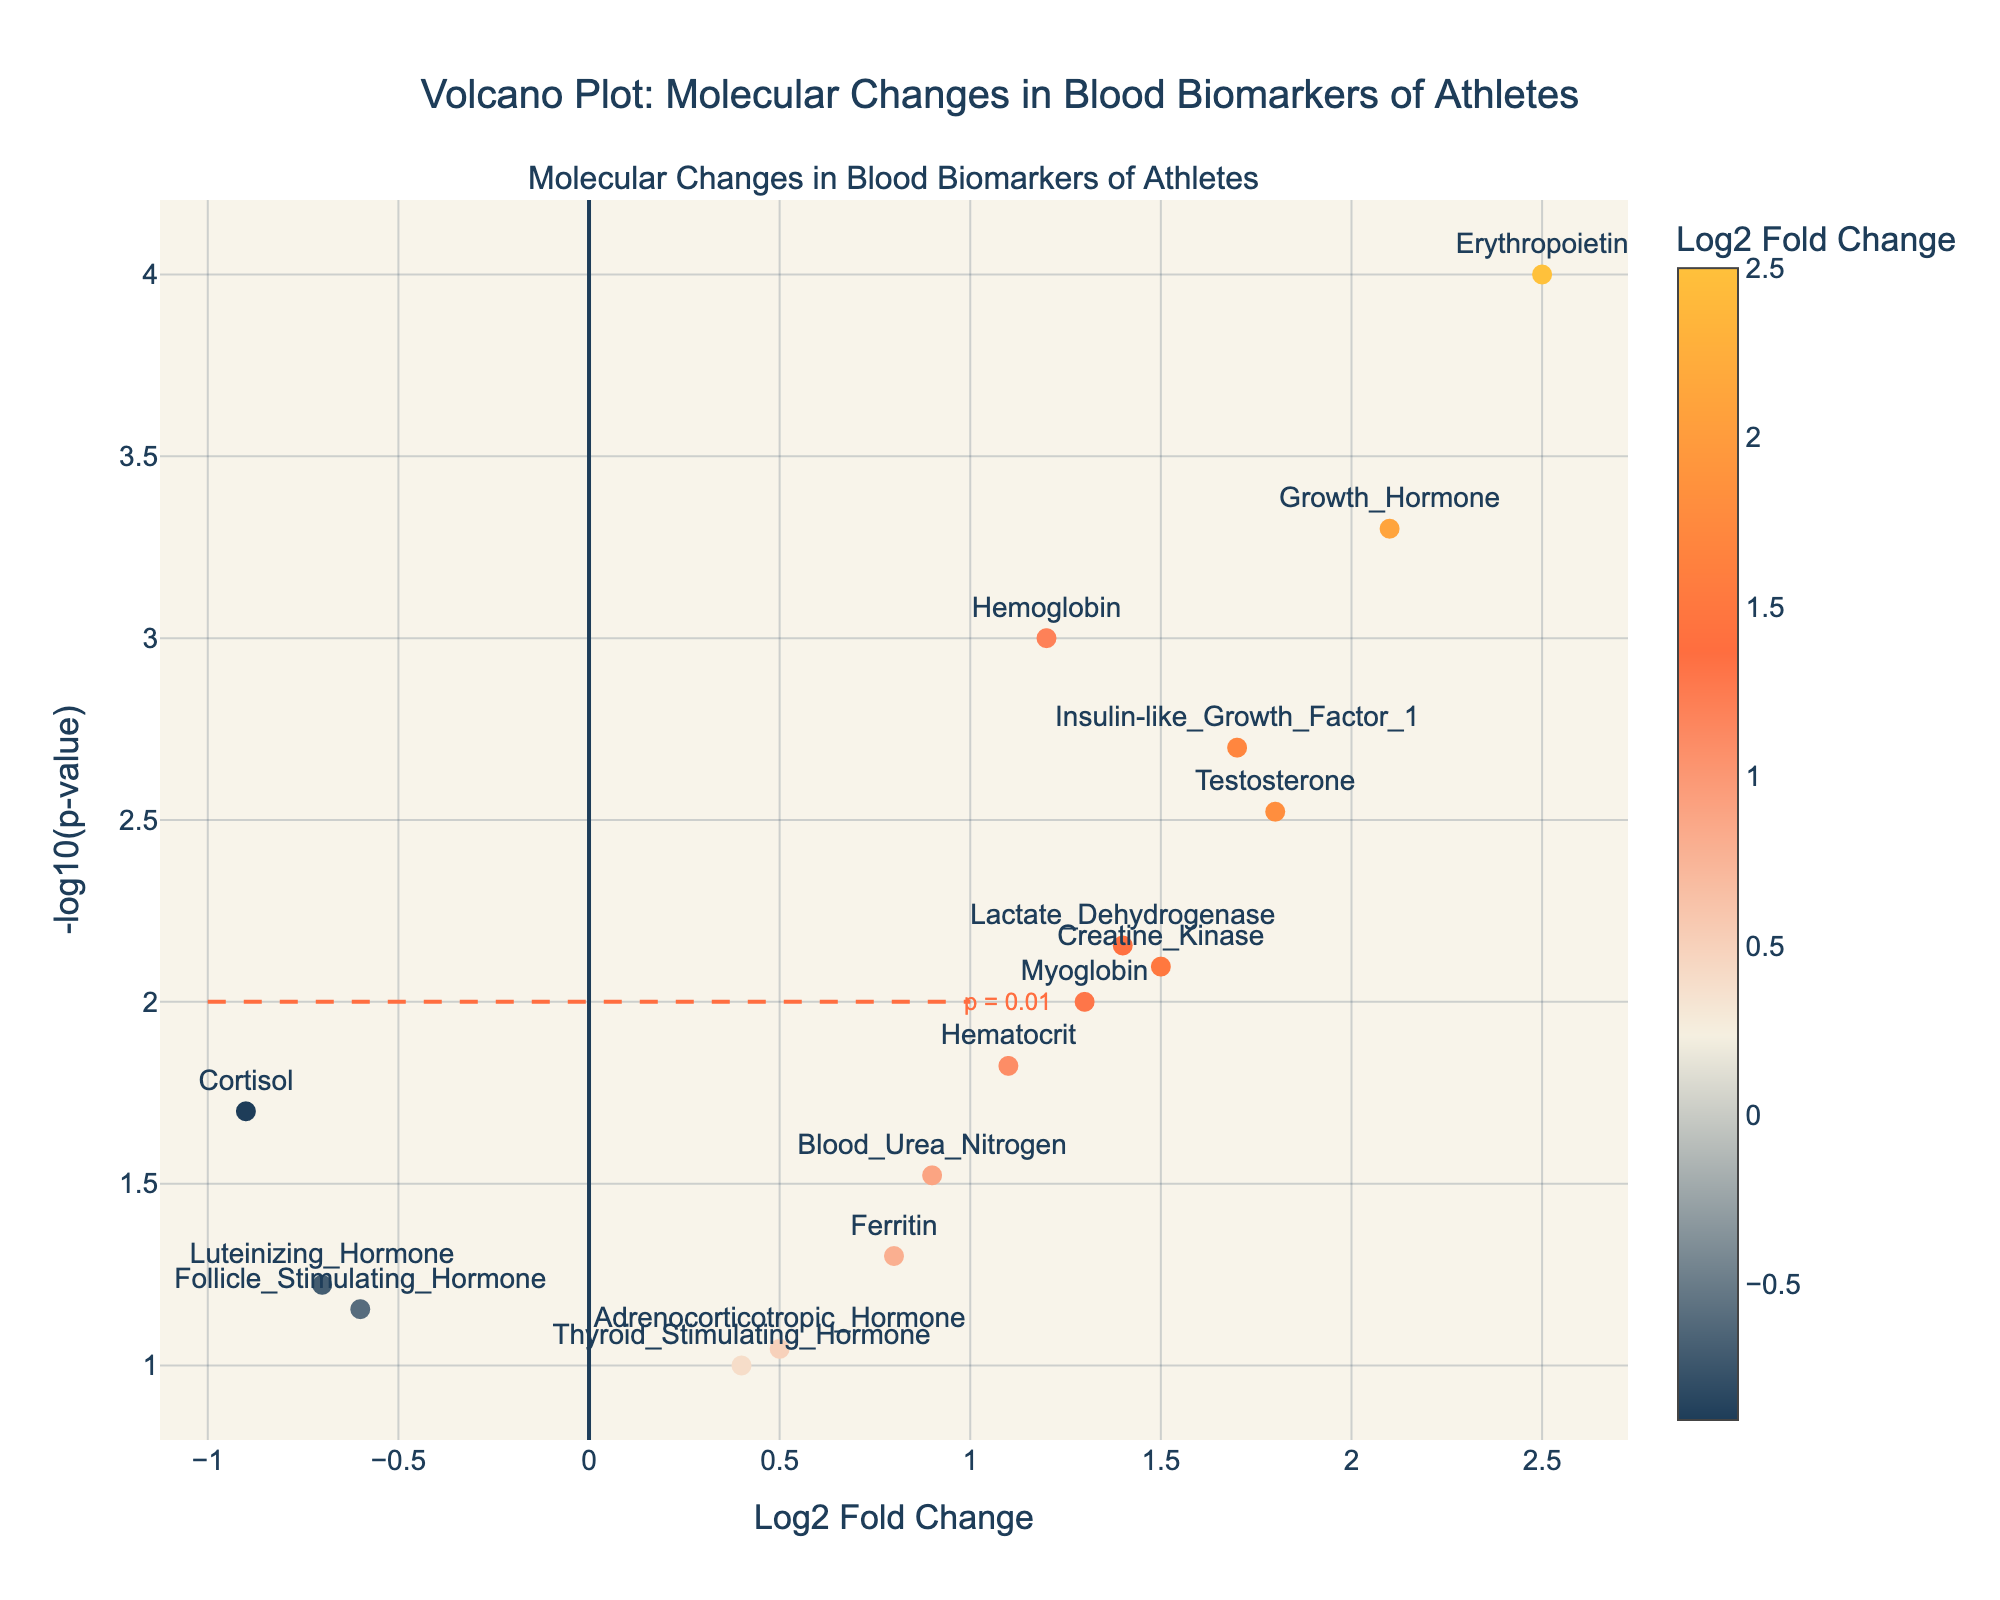Which blood biomarker has the highest log2 fold change? The log2 fold change can be read from the x-axis for each biomarker. The highest log2 fold change is for Erythropoietin (2.5).
Answer: Erythropoietin What is the p-value for Erythropoietin? The p-value is derived from the negative logarithm on the y-axis. For Erythropoietin at 2.5 log2 fold change, the -log10(p-value) is very high at around 4, which corresponds to a p-value of 10^(-4), i.e., 0.0001.
Answer: 0.0001 Which sports discipline shows the least significant change in a blood biomarker? The least significant change is indicated by the lowest -log10(p-value). Checking the bottom-most points, Thyroid Stimulating Hormone and Adrenocorticotropic Hormone for Basketball have -log10(p-values) around 1, thus p-values of 0.1 and 0.09 respectively.
Answer: Basketball Are there any biomarkers showing reduced levels in athletes compared to non-athletes? A reduced level in athletes would be reflected as a negative log2 fold change. Checking for negative x-axis values, Cortisol, Luteinizing Hormone, and Follicle Stimulating Hormone show reduced levels.
Answer: Yes How many biomarkers have a p-value less than 0.01? To find how many biomarkers have a p-value < 0.01, check for those with a y-axis value greater than 2 (-log10(0.01) = 2). Hemoglobin, Erythropoietin, Testosterone, Growth Hormone, Insulin-like Growth Factor 1, and Lactate Dehydrogenase qualify.
Answer: 6 Which sports have biomarkers with both high log2 fold change and significant p-values? High log2 fold change is taken as >1.5 and significant p-values as <0.01. Erythropoietin (Cycling), Testosterone (Weightlifting), Growth Hormone (Weightlifting), and Insulin-like Growth Factor 1 (Swimming) meet these criteria.
Answer: Cycling, Weightlifting, Swimming What can be inferred from the position of the Cortisol biomarker? Cortisol's log2 fold change is negative, showing reduced levels (-0.9), and its p-value is 0.02, which indicates moderate significance.
Answer: Reduced levels and moderately significant Does any sport exclusively show heightened levels of a particular biomarker? Exclusive heightened levels (positive log2 fold change greater than 1 and significant p-value) can be checked for uniqueness per sport. Cycling shows Erythropoietin (2.5, highly significant) uniquely.
Answer: Cycling 